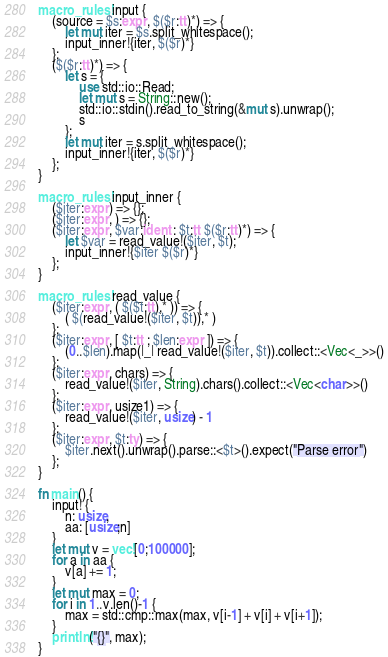<code> <loc_0><loc_0><loc_500><loc_500><_Rust_>macro_rules! input {
    (source = $s:expr, $($r:tt)*) => {
        let mut iter = $s.split_whitespace();
        input_inner!{iter, $($r)*}
    };
    ($($r:tt)*) => {
        let s = {
            use std::io::Read;
            let mut s = String::new();
            std::io::stdin().read_to_string(&mut s).unwrap();
            s
        };
        let mut iter = s.split_whitespace();
        input_inner!{iter, $($r)*}
    };
}

macro_rules! input_inner {
    ($iter:expr) => {};
    ($iter:expr, ) => {};
    ($iter:expr, $var:ident : $t:tt $($r:tt)*) => {
        let $var = read_value!($iter, $t);
        input_inner!{$iter $($r)*}
    };
}

macro_rules! read_value {
    ($iter:expr, ( $($t:tt),* )) => {
        ( $(read_value!($iter, $t)),* )
    };
    ($iter:expr, [ $t:tt ; $len:expr ]) => {
        (0..$len).map(|_| read_value!($iter, $t)).collect::<Vec<_>>()
    };
    ($iter:expr, chars) => {
        read_value!($iter, String).chars().collect::<Vec<char>>()
    };
    ($iter:expr, usize1) => {
        read_value!($iter, usize) - 1
    };
    ($iter:expr, $t:ty) => {
        $iter.next().unwrap().parse::<$t>().expect("Parse error")
    };
}

fn main() {
    input! {
        n: usize,
        aa: [usize;n]
    }
    let mut v = vec![0;100000];
    for a in aa {
        v[a] += 1;
    }
    let mut max = 0;
    for i in 1..v.len()-1 {
        max = std::cmp::max(max, v[i-1] + v[i] + v[i+1]);
    }
    println!("{}", max);
}
</code> 